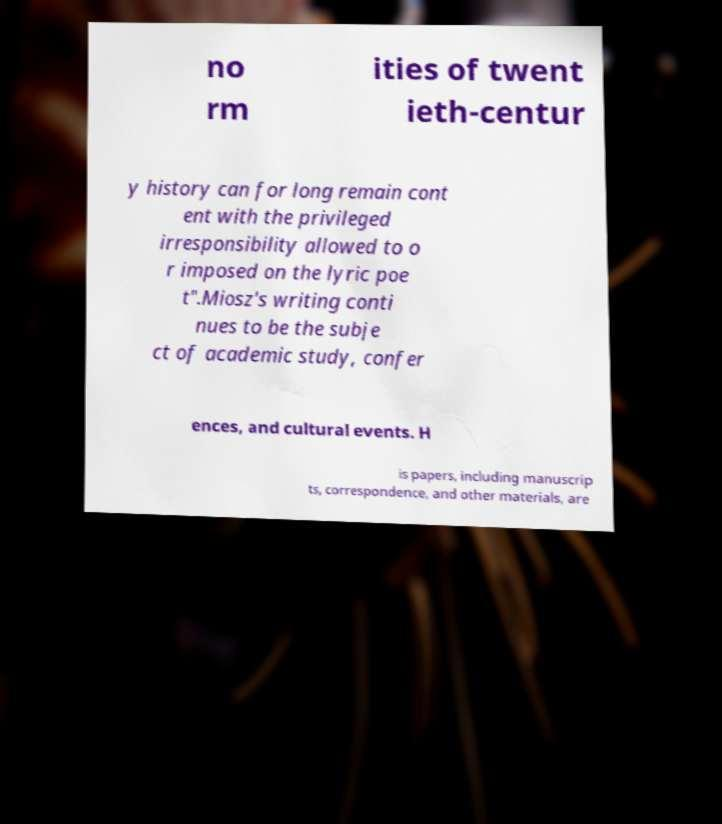Can you accurately transcribe the text from the provided image for me? no rm ities of twent ieth-centur y history can for long remain cont ent with the privileged irresponsibility allowed to o r imposed on the lyric poe t".Miosz's writing conti nues to be the subje ct of academic study, confer ences, and cultural events. H is papers, including manuscrip ts, correspondence, and other materials, are 